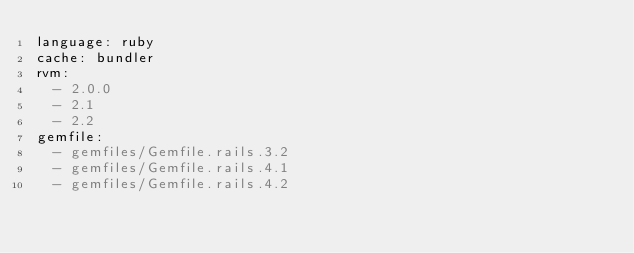Convert code to text. <code><loc_0><loc_0><loc_500><loc_500><_YAML_>language: ruby
cache: bundler
rvm:
  - 2.0.0
  - 2.1
  - 2.2
gemfile:
  - gemfiles/Gemfile.rails.3.2
  - gemfiles/Gemfile.rails.4.1
  - gemfiles/Gemfile.rails.4.2
</code> 